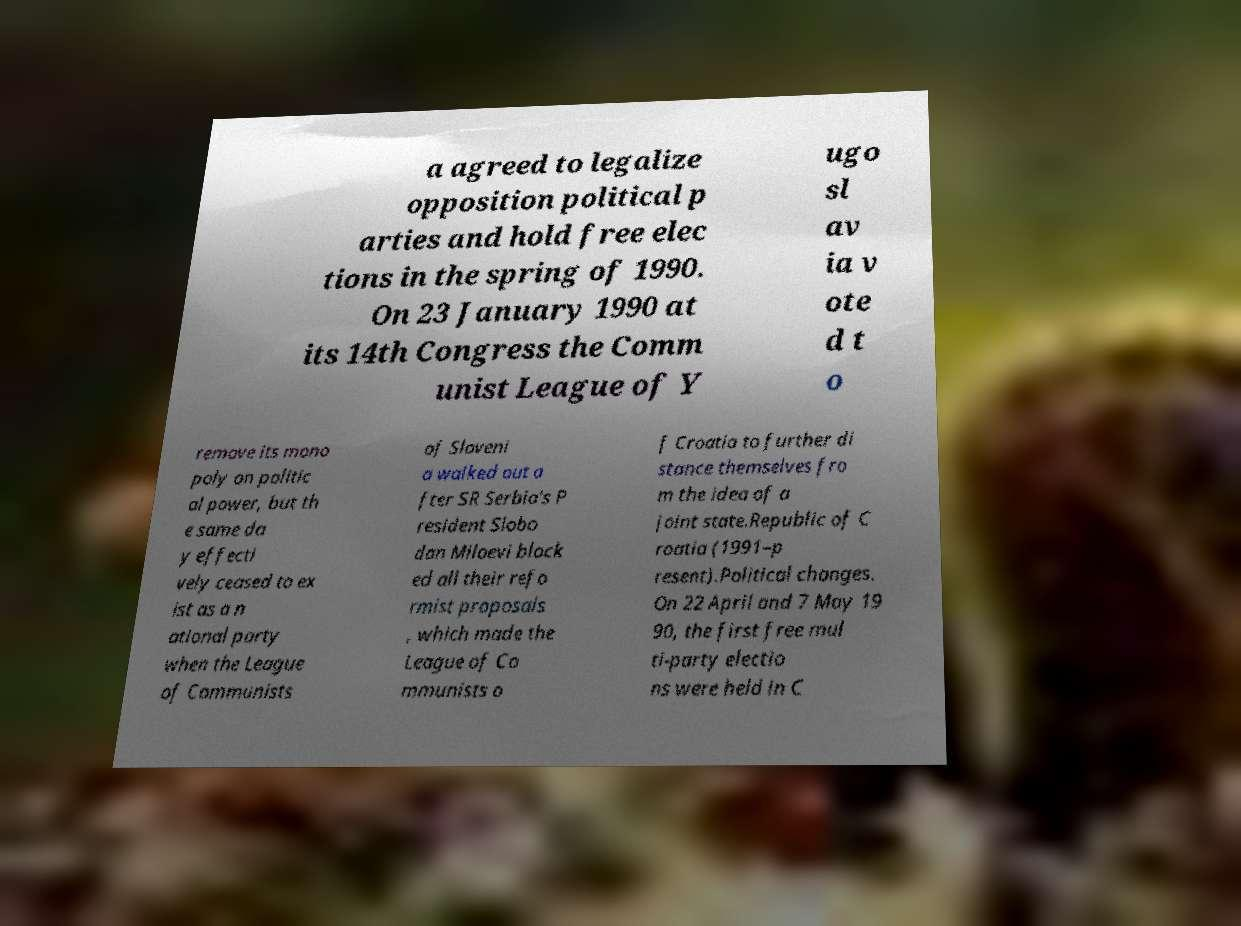Could you assist in decoding the text presented in this image and type it out clearly? a agreed to legalize opposition political p arties and hold free elec tions in the spring of 1990. On 23 January 1990 at its 14th Congress the Comm unist League of Y ugo sl av ia v ote d t o remove its mono poly on politic al power, but th e same da y effecti vely ceased to ex ist as a n ational party when the League of Communists of Sloveni a walked out a fter SR Serbia's P resident Slobo dan Miloevi block ed all their refo rmist proposals , which made the League of Co mmunists o f Croatia to further di stance themselves fro m the idea of a joint state.Republic of C roatia (1991–p resent).Political changes. On 22 April and 7 May 19 90, the first free mul ti-party electio ns were held in C 